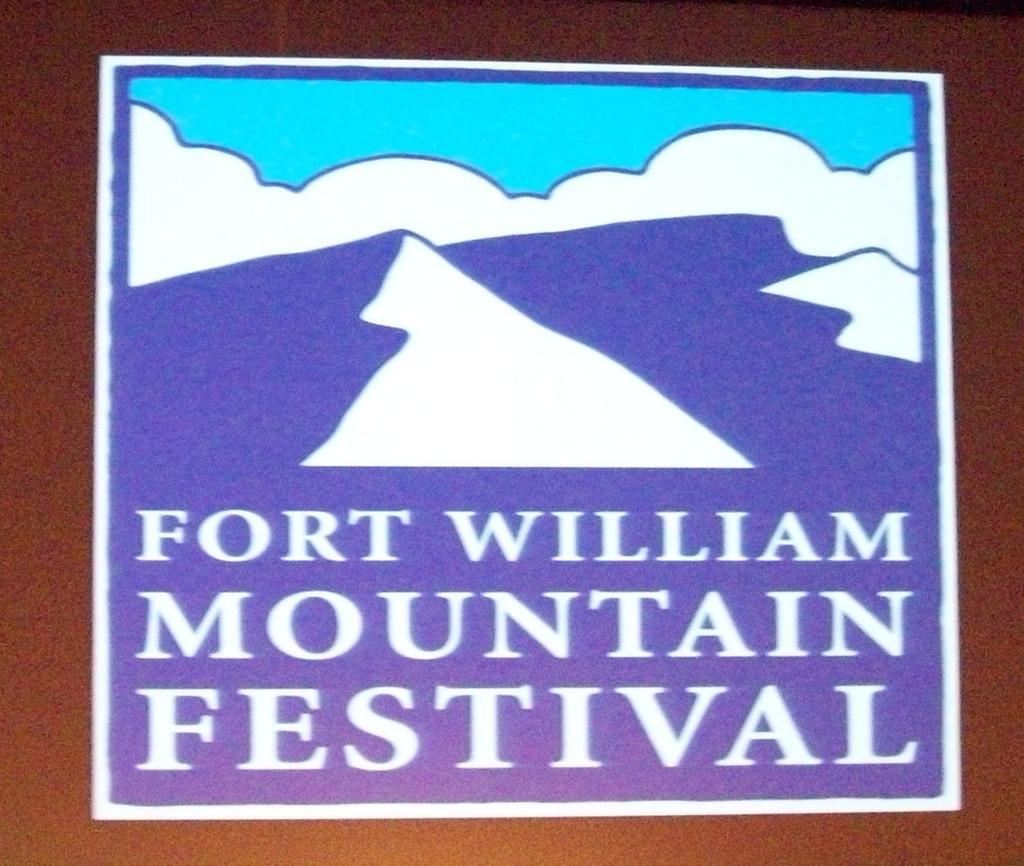<image>
Share a concise interpretation of the image provided. the logo for the fort william mountain festival with mountains in the background. 